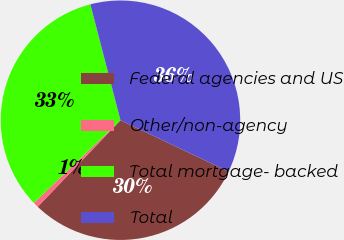<chart> <loc_0><loc_0><loc_500><loc_500><pie_chart><fcel>Federal agencies and US<fcel>Other/non-agency<fcel>Total mortgage- backed<fcel>Total<nl><fcel>30.08%<fcel>0.73%<fcel>33.09%<fcel>36.1%<nl></chart> 